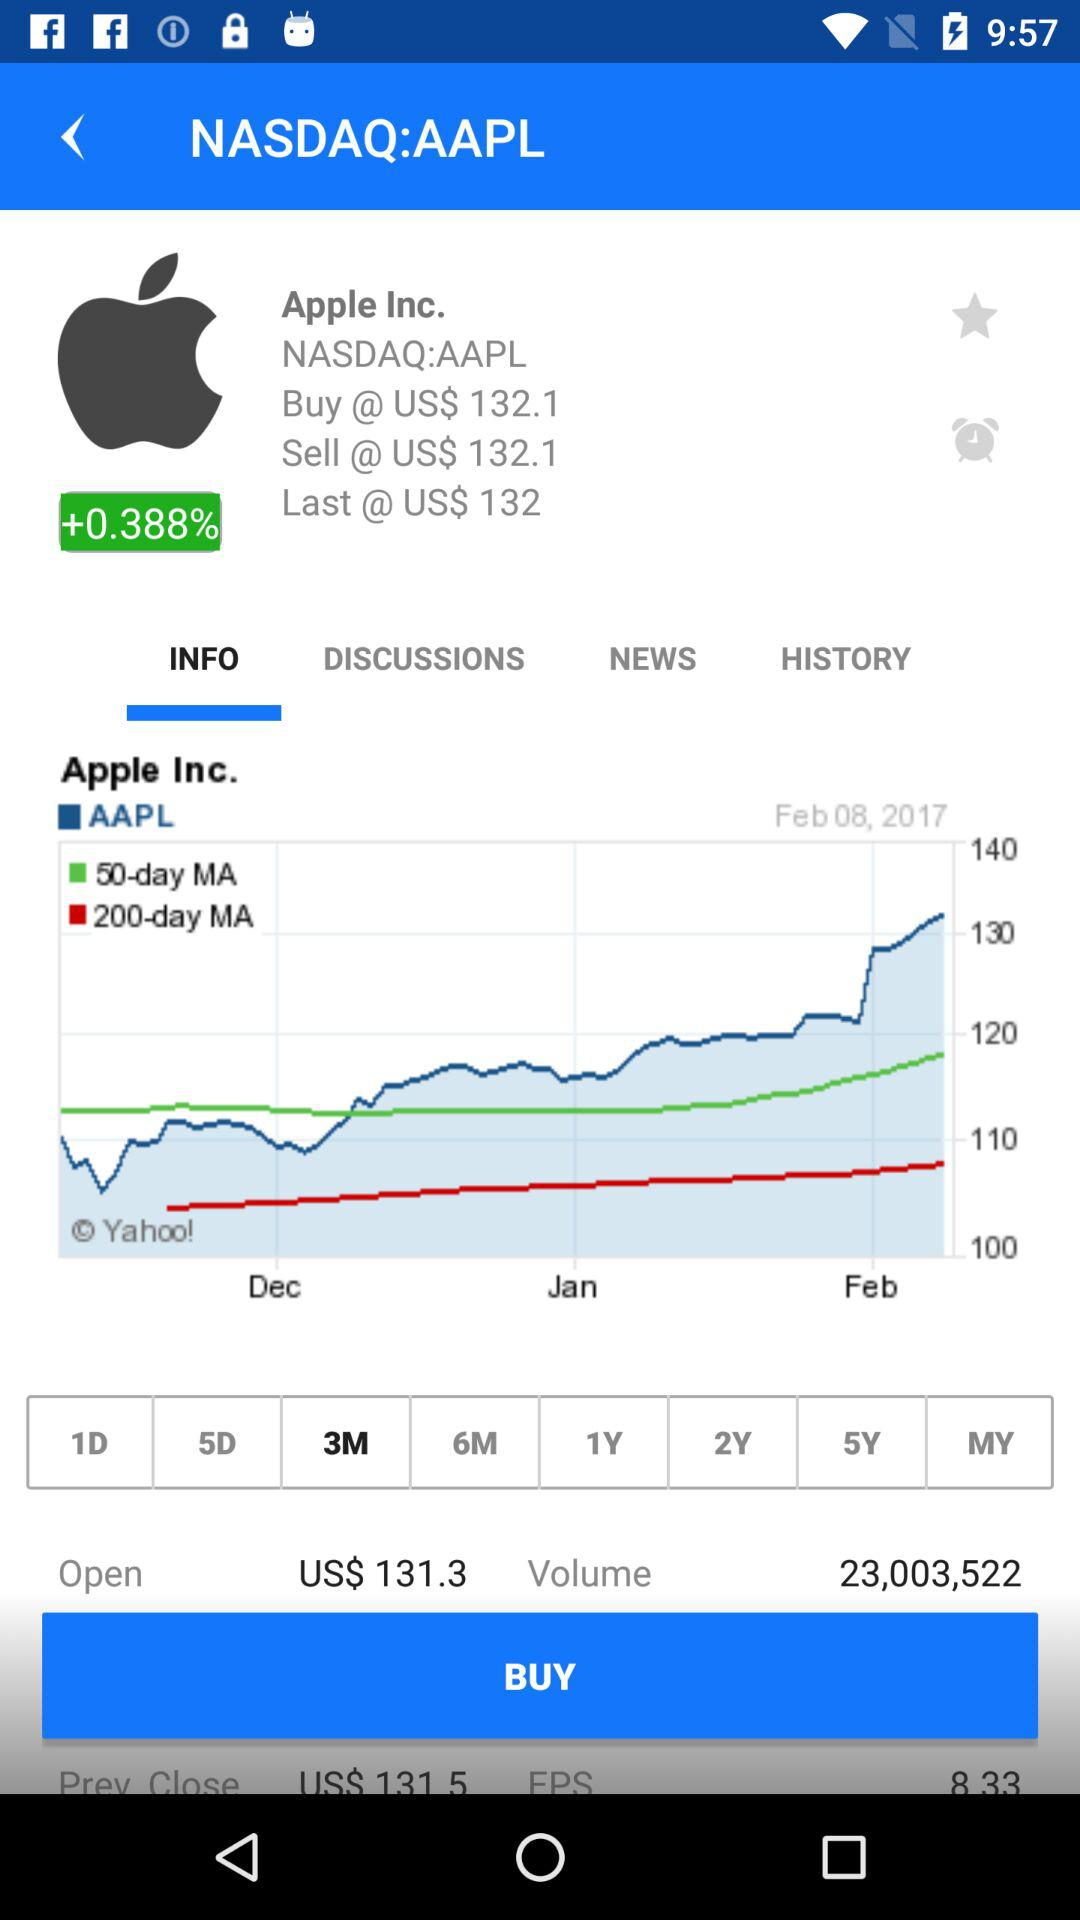What tab is selected? The selected tab is "INFO". 